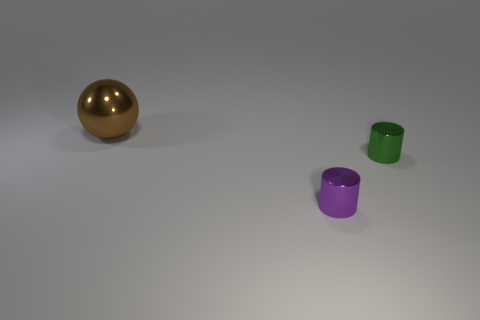How would you describe the arrangement of the objects in this space? The objects are placed with ample space between them, arranged in a staggered formation that leads the eye from the front to the back of the image, creating a sense of depth. 